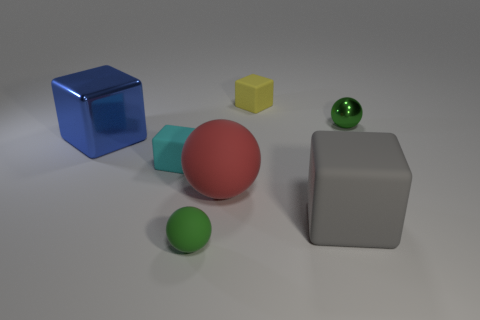Subtract all large metal blocks. How many blocks are left? 3 Add 2 small yellow matte cubes. How many objects exist? 9 Subtract all green balls. How many balls are left? 1 Subtract all spheres. How many objects are left? 4 Subtract all purple spheres. Subtract all brown cylinders. How many spheres are left? 3 Subtract all gray blocks. How many green balls are left? 2 Subtract all shiny spheres. Subtract all tiny green rubber spheres. How many objects are left? 5 Add 4 big gray matte blocks. How many big gray matte blocks are left? 5 Add 3 blue objects. How many blue objects exist? 4 Subtract 1 gray blocks. How many objects are left? 6 